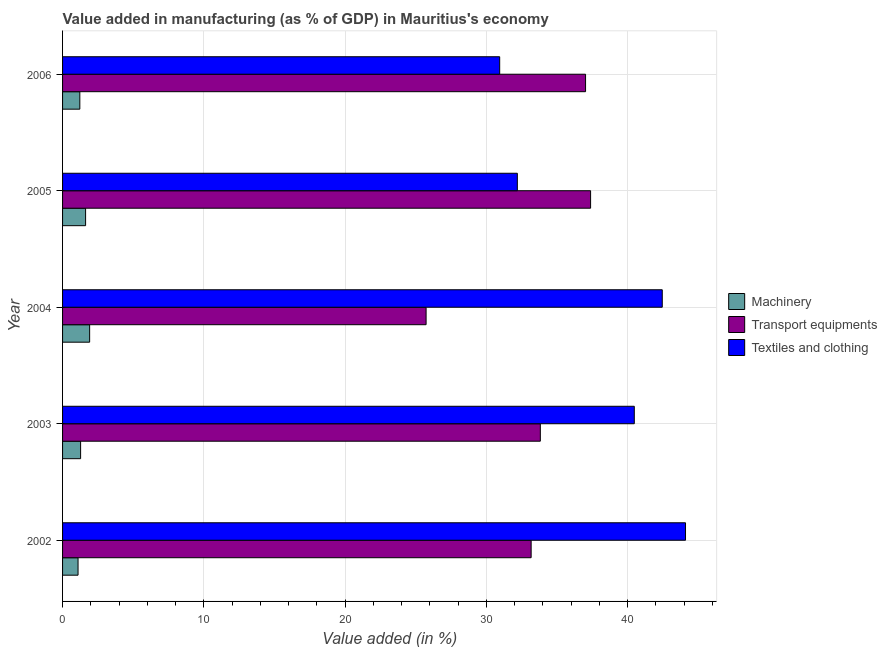How many different coloured bars are there?
Provide a short and direct response. 3. How many bars are there on the 1st tick from the bottom?
Ensure brevity in your answer.  3. In how many cases, is the number of bars for a given year not equal to the number of legend labels?
Ensure brevity in your answer.  0. What is the value added in manufacturing machinery in 2002?
Provide a succinct answer. 1.1. Across all years, what is the maximum value added in manufacturing machinery?
Give a very brief answer. 1.92. Across all years, what is the minimum value added in manufacturing transport equipments?
Your response must be concise. 25.73. In which year was the value added in manufacturing textile and clothing minimum?
Make the answer very short. 2006. What is the total value added in manufacturing transport equipments in the graph?
Make the answer very short. 167.1. What is the difference between the value added in manufacturing textile and clothing in 2004 and that in 2005?
Provide a short and direct response. 10.26. What is the difference between the value added in manufacturing textile and clothing in 2002 and the value added in manufacturing transport equipments in 2004?
Your answer should be very brief. 18.36. What is the average value added in manufacturing textile and clothing per year?
Offer a very short reply. 38.02. In the year 2003, what is the difference between the value added in manufacturing transport equipments and value added in manufacturing textile and clothing?
Give a very brief answer. -6.65. In how many years, is the value added in manufacturing machinery greater than 30 %?
Make the answer very short. 0. What is the ratio of the value added in manufacturing machinery in 2002 to that in 2006?
Keep it short and to the point. 0.9. Is the value added in manufacturing textile and clothing in 2002 less than that in 2006?
Give a very brief answer. No. Is the difference between the value added in manufacturing machinery in 2004 and 2006 greater than the difference between the value added in manufacturing textile and clothing in 2004 and 2006?
Keep it short and to the point. No. What is the difference between the highest and the second highest value added in manufacturing transport equipments?
Give a very brief answer. 0.35. What is the difference between the highest and the lowest value added in manufacturing machinery?
Your answer should be very brief. 0.82. In how many years, is the value added in manufacturing machinery greater than the average value added in manufacturing machinery taken over all years?
Your response must be concise. 2. Is the sum of the value added in manufacturing transport equipments in 2003 and 2005 greater than the maximum value added in manufacturing textile and clothing across all years?
Your response must be concise. Yes. What does the 1st bar from the top in 2002 represents?
Offer a very short reply. Textiles and clothing. What does the 3rd bar from the bottom in 2004 represents?
Provide a succinct answer. Textiles and clothing. How many years are there in the graph?
Provide a succinct answer. 5. What is the difference between two consecutive major ticks on the X-axis?
Give a very brief answer. 10. Does the graph contain grids?
Give a very brief answer. Yes. Where does the legend appear in the graph?
Offer a terse response. Center right. How many legend labels are there?
Your answer should be compact. 3. What is the title of the graph?
Your answer should be compact. Value added in manufacturing (as % of GDP) in Mauritius's economy. Does "Renewable sources" appear as one of the legend labels in the graph?
Make the answer very short. No. What is the label or title of the X-axis?
Keep it short and to the point. Value added (in %). What is the label or title of the Y-axis?
Offer a terse response. Year. What is the Value added (in %) in Machinery in 2002?
Provide a succinct answer. 1.1. What is the Value added (in %) in Transport equipments in 2002?
Your response must be concise. 33.16. What is the Value added (in %) of Textiles and clothing in 2002?
Your response must be concise. 44.09. What is the Value added (in %) of Machinery in 2003?
Give a very brief answer. 1.28. What is the Value added (in %) in Transport equipments in 2003?
Offer a terse response. 33.81. What is the Value added (in %) in Textiles and clothing in 2003?
Offer a terse response. 40.47. What is the Value added (in %) in Machinery in 2004?
Your answer should be compact. 1.92. What is the Value added (in %) of Transport equipments in 2004?
Provide a short and direct response. 25.73. What is the Value added (in %) in Textiles and clothing in 2004?
Give a very brief answer. 42.44. What is the Value added (in %) of Machinery in 2005?
Provide a short and direct response. 1.63. What is the Value added (in %) in Transport equipments in 2005?
Provide a succinct answer. 37.37. What is the Value added (in %) in Textiles and clothing in 2005?
Your answer should be very brief. 32.19. What is the Value added (in %) in Machinery in 2006?
Provide a succinct answer. 1.22. What is the Value added (in %) in Transport equipments in 2006?
Keep it short and to the point. 37.02. What is the Value added (in %) in Textiles and clothing in 2006?
Ensure brevity in your answer.  30.94. Across all years, what is the maximum Value added (in %) in Machinery?
Provide a short and direct response. 1.92. Across all years, what is the maximum Value added (in %) in Transport equipments?
Provide a short and direct response. 37.37. Across all years, what is the maximum Value added (in %) of Textiles and clothing?
Your answer should be compact. 44.09. Across all years, what is the minimum Value added (in %) in Machinery?
Your response must be concise. 1.1. Across all years, what is the minimum Value added (in %) of Transport equipments?
Offer a terse response. 25.73. Across all years, what is the minimum Value added (in %) in Textiles and clothing?
Make the answer very short. 30.94. What is the total Value added (in %) in Machinery in the graph?
Give a very brief answer. 7.14. What is the total Value added (in %) of Transport equipments in the graph?
Your answer should be compact. 167.1. What is the total Value added (in %) in Textiles and clothing in the graph?
Offer a very short reply. 190.13. What is the difference between the Value added (in %) of Machinery in 2002 and that in 2003?
Keep it short and to the point. -0.18. What is the difference between the Value added (in %) in Transport equipments in 2002 and that in 2003?
Your answer should be compact. -0.65. What is the difference between the Value added (in %) of Textiles and clothing in 2002 and that in 2003?
Give a very brief answer. 3.63. What is the difference between the Value added (in %) of Machinery in 2002 and that in 2004?
Provide a short and direct response. -0.82. What is the difference between the Value added (in %) of Transport equipments in 2002 and that in 2004?
Make the answer very short. 7.43. What is the difference between the Value added (in %) of Textiles and clothing in 2002 and that in 2004?
Provide a succinct answer. 1.65. What is the difference between the Value added (in %) in Machinery in 2002 and that in 2005?
Give a very brief answer. -0.53. What is the difference between the Value added (in %) of Transport equipments in 2002 and that in 2005?
Make the answer very short. -4.21. What is the difference between the Value added (in %) in Textiles and clothing in 2002 and that in 2005?
Provide a succinct answer. 11.9. What is the difference between the Value added (in %) of Machinery in 2002 and that in 2006?
Keep it short and to the point. -0.13. What is the difference between the Value added (in %) in Transport equipments in 2002 and that in 2006?
Give a very brief answer. -3.85. What is the difference between the Value added (in %) in Textiles and clothing in 2002 and that in 2006?
Ensure brevity in your answer.  13.15. What is the difference between the Value added (in %) in Machinery in 2003 and that in 2004?
Your response must be concise. -0.64. What is the difference between the Value added (in %) in Transport equipments in 2003 and that in 2004?
Give a very brief answer. 8.09. What is the difference between the Value added (in %) of Textiles and clothing in 2003 and that in 2004?
Provide a short and direct response. -1.98. What is the difference between the Value added (in %) in Machinery in 2003 and that in 2005?
Offer a very short reply. -0.35. What is the difference between the Value added (in %) in Transport equipments in 2003 and that in 2005?
Ensure brevity in your answer.  -3.56. What is the difference between the Value added (in %) of Textiles and clothing in 2003 and that in 2005?
Ensure brevity in your answer.  8.28. What is the difference between the Value added (in %) of Machinery in 2003 and that in 2006?
Make the answer very short. 0.06. What is the difference between the Value added (in %) in Transport equipments in 2003 and that in 2006?
Provide a short and direct response. -3.2. What is the difference between the Value added (in %) of Textiles and clothing in 2003 and that in 2006?
Provide a succinct answer. 9.53. What is the difference between the Value added (in %) in Machinery in 2004 and that in 2005?
Ensure brevity in your answer.  0.29. What is the difference between the Value added (in %) in Transport equipments in 2004 and that in 2005?
Ensure brevity in your answer.  -11.64. What is the difference between the Value added (in %) in Textiles and clothing in 2004 and that in 2005?
Give a very brief answer. 10.26. What is the difference between the Value added (in %) of Machinery in 2004 and that in 2006?
Your response must be concise. 0.69. What is the difference between the Value added (in %) of Transport equipments in 2004 and that in 2006?
Make the answer very short. -11.29. What is the difference between the Value added (in %) in Textiles and clothing in 2004 and that in 2006?
Your answer should be very brief. 11.51. What is the difference between the Value added (in %) of Machinery in 2005 and that in 2006?
Keep it short and to the point. 0.41. What is the difference between the Value added (in %) in Transport equipments in 2005 and that in 2006?
Keep it short and to the point. 0.36. What is the difference between the Value added (in %) of Textiles and clothing in 2005 and that in 2006?
Offer a terse response. 1.25. What is the difference between the Value added (in %) of Machinery in 2002 and the Value added (in %) of Transport equipments in 2003?
Offer a very short reply. -32.72. What is the difference between the Value added (in %) in Machinery in 2002 and the Value added (in %) in Textiles and clothing in 2003?
Provide a succinct answer. -39.37. What is the difference between the Value added (in %) of Transport equipments in 2002 and the Value added (in %) of Textiles and clothing in 2003?
Ensure brevity in your answer.  -7.3. What is the difference between the Value added (in %) of Machinery in 2002 and the Value added (in %) of Transport equipments in 2004?
Your answer should be compact. -24.63. What is the difference between the Value added (in %) in Machinery in 2002 and the Value added (in %) in Textiles and clothing in 2004?
Keep it short and to the point. -41.35. What is the difference between the Value added (in %) in Transport equipments in 2002 and the Value added (in %) in Textiles and clothing in 2004?
Make the answer very short. -9.28. What is the difference between the Value added (in %) of Machinery in 2002 and the Value added (in %) of Transport equipments in 2005?
Give a very brief answer. -36.28. What is the difference between the Value added (in %) of Machinery in 2002 and the Value added (in %) of Textiles and clothing in 2005?
Provide a short and direct response. -31.09. What is the difference between the Value added (in %) of Transport equipments in 2002 and the Value added (in %) of Textiles and clothing in 2005?
Keep it short and to the point. 0.98. What is the difference between the Value added (in %) in Machinery in 2002 and the Value added (in %) in Transport equipments in 2006?
Your answer should be compact. -35.92. What is the difference between the Value added (in %) in Machinery in 2002 and the Value added (in %) in Textiles and clothing in 2006?
Ensure brevity in your answer.  -29.84. What is the difference between the Value added (in %) in Transport equipments in 2002 and the Value added (in %) in Textiles and clothing in 2006?
Your response must be concise. 2.23. What is the difference between the Value added (in %) in Machinery in 2003 and the Value added (in %) in Transport equipments in 2004?
Your response must be concise. -24.45. What is the difference between the Value added (in %) of Machinery in 2003 and the Value added (in %) of Textiles and clothing in 2004?
Keep it short and to the point. -41.17. What is the difference between the Value added (in %) of Transport equipments in 2003 and the Value added (in %) of Textiles and clothing in 2004?
Your answer should be very brief. -8.63. What is the difference between the Value added (in %) in Machinery in 2003 and the Value added (in %) in Transport equipments in 2005?
Offer a very short reply. -36.09. What is the difference between the Value added (in %) in Machinery in 2003 and the Value added (in %) in Textiles and clothing in 2005?
Make the answer very short. -30.91. What is the difference between the Value added (in %) in Transport equipments in 2003 and the Value added (in %) in Textiles and clothing in 2005?
Ensure brevity in your answer.  1.63. What is the difference between the Value added (in %) of Machinery in 2003 and the Value added (in %) of Transport equipments in 2006?
Offer a very short reply. -35.74. What is the difference between the Value added (in %) in Machinery in 2003 and the Value added (in %) in Textiles and clothing in 2006?
Provide a short and direct response. -29.66. What is the difference between the Value added (in %) in Transport equipments in 2003 and the Value added (in %) in Textiles and clothing in 2006?
Give a very brief answer. 2.88. What is the difference between the Value added (in %) of Machinery in 2004 and the Value added (in %) of Transport equipments in 2005?
Provide a succinct answer. -35.46. What is the difference between the Value added (in %) in Machinery in 2004 and the Value added (in %) in Textiles and clothing in 2005?
Offer a very short reply. -30.27. What is the difference between the Value added (in %) in Transport equipments in 2004 and the Value added (in %) in Textiles and clothing in 2005?
Make the answer very short. -6.46. What is the difference between the Value added (in %) of Machinery in 2004 and the Value added (in %) of Transport equipments in 2006?
Provide a short and direct response. -35.1. What is the difference between the Value added (in %) of Machinery in 2004 and the Value added (in %) of Textiles and clothing in 2006?
Your answer should be compact. -29.02. What is the difference between the Value added (in %) of Transport equipments in 2004 and the Value added (in %) of Textiles and clothing in 2006?
Your answer should be very brief. -5.21. What is the difference between the Value added (in %) of Machinery in 2005 and the Value added (in %) of Transport equipments in 2006?
Your answer should be very brief. -35.39. What is the difference between the Value added (in %) of Machinery in 2005 and the Value added (in %) of Textiles and clothing in 2006?
Ensure brevity in your answer.  -29.31. What is the difference between the Value added (in %) in Transport equipments in 2005 and the Value added (in %) in Textiles and clothing in 2006?
Keep it short and to the point. 6.43. What is the average Value added (in %) of Machinery per year?
Offer a very short reply. 1.43. What is the average Value added (in %) of Transport equipments per year?
Your response must be concise. 33.42. What is the average Value added (in %) of Textiles and clothing per year?
Your answer should be compact. 38.03. In the year 2002, what is the difference between the Value added (in %) in Machinery and Value added (in %) in Transport equipments?
Offer a very short reply. -32.07. In the year 2002, what is the difference between the Value added (in %) of Machinery and Value added (in %) of Textiles and clothing?
Your response must be concise. -42.99. In the year 2002, what is the difference between the Value added (in %) of Transport equipments and Value added (in %) of Textiles and clothing?
Offer a very short reply. -10.93. In the year 2003, what is the difference between the Value added (in %) in Machinery and Value added (in %) in Transport equipments?
Your answer should be compact. -32.54. In the year 2003, what is the difference between the Value added (in %) of Machinery and Value added (in %) of Textiles and clothing?
Provide a short and direct response. -39.19. In the year 2003, what is the difference between the Value added (in %) in Transport equipments and Value added (in %) in Textiles and clothing?
Provide a succinct answer. -6.65. In the year 2004, what is the difference between the Value added (in %) in Machinery and Value added (in %) in Transport equipments?
Your answer should be compact. -23.81. In the year 2004, what is the difference between the Value added (in %) of Machinery and Value added (in %) of Textiles and clothing?
Keep it short and to the point. -40.53. In the year 2004, what is the difference between the Value added (in %) in Transport equipments and Value added (in %) in Textiles and clothing?
Your answer should be very brief. -16.72. In the year 2005, what is the difference between the Value added (in %) in Machinery and Value added (in %) in Transport equipments?
Your answer should be very brief. -35.74. In the year 2005, what is the difference between the Value added (in %) of Machinery and Value added (in %) of Textiles and clothing?
Provide a short and direct response. -30.56. In the year 2005, what is the difference between the Value added (in %) in Transport equipments and Value added (in %) in Textiles and clothing?
Provide a short and direct response. 5.18. In the year 2006, what is the difference between the Value added (in %) of Machinery and Value added (in %) of Transport equipments?
Keep it short and to the point. -35.79. In the year 2006, what is the difference between the Value added (in %) in Machinery and Value added (in %) in Textiles and clothing?
Your answer should be compact. -29.72. In the year 2006, what is the difference between the Value added (in %) of Transport equipments and Value added (in %) of Textiles and clothing?
Your answer should be compact. 6.08. What is the ratio of the Value added (in %) of Machinery in 2002 to that in 2003?
Your response must be concise. 0.86. What is the ratio of the Value added (in %) of Transport equipments in 2002 to that in 2003?
Keep it short and to the point. 0.98. What is the ratio of the Value added (in %) of Textiles and clothing in 2002 to that in 2003?
Your answer should be very brief. 1.09. What is the ratio of the Value added (in %) in Machinery in 2002 to that in 2004?
Your answer should be compact. 0.57. What is the ratio of the Value added (in %) in Transport equipments in 2002 to that in 2004?
Ensure brevity in your answer.  1.29. What is the ratio of the Value added (in %) in Textiles and clothing in 2002 to that in 2004?
Make the answer very short. 1.04. What is the ratio of the Value added (in %) in Machinery in 2002 to that in 2005?
Offer a terse response. 0.67. What is the ratio of the Value added (in %) in Transport equipments in 2002 to that in 2005?
Give a very brief answer. 0.89. What is the ratio of the Value added (in %) in Textiles and clothing in 2002 to that in 2005?
Your answer should be very brief. 1.37. What is the ratio of the Value added (in %) of Machinery in 2002 to that in 2006?
Keep it short and to the point. 0.9. What is the ratio of the Value added (in %) of Transport equipments in 2002 to that in 2006?
Ensure brevity in your answer.  0.9. What is the ratio of the Value added (in %) in Textiles and clothing in 2002 to that in 2006?
Your response must be concise. 1.43. What is the ratio of the Value added (in %) of Transport equipments in 2003 to that in 2004?
Your response must be concise. 1.31. What is the ratio of the Value added (in %) of Textiles and clothing in 2003 to that in 2004?
Your answer should be very brief. 0.95. What is the ratio of the Value added (in %) in Machinery in 2003 to that in 2005?
Your response must be concise. 0.78. What is the ratio of the Value added (in %) of Transport equipments in 2003 to that in 2005?
Offer a terse response. 0.9. What is the ratio of the Value added (in %) of Textiles and clothing in 2003 to that in 2005?
Provide a succinct answer. 1.26. What is the ratio of the Value added (in %) in Machinery in 2003 to that in 2006?
Ensure brevity in your answer.  1.05. What is the ratio of the Value added (in %) of Transport equipments in 2003 to that in 2006?
Offer a very short reply. 0.91. What is the ratio of the Value added (in %) in Textiles and clothing in 2003 to that in 2006?
Your response must be concise. 1.31. What is the ratio of the Value added (in %) of Machinery in 2004 to that in 2005?
Offer a terse response. 1.18. What is the ratio of the Value added (in %) of Transport equipments in 2004 to that in 2005?
Offer a terse response. 0.69. What is the ratio of the Value added (in %) in Textiles and clothing in 2004 to that in 2005?
Keep it short and to the point. 1.32. What is the ratio of the Value added (in %) in Machinery in 2004 to that in 2006?
Offer a terse response. 1.57. What is the ratio of the Value added (in %) in Transport equipments in 2004 to that in 2006?
Offer a terse response. 0.7. What is the ratio of the Value added (in %) of Textiles and clothing in 2004 to that in 2006?
Provide a short and direct response. 1.37. What is the ratio of the Value added (in %) of Machinery in 2005 to that in 2006?
Ensure brevity in your answer.  1.33. What is the ratio of the Value added (in %) of Transport equipments in 2005 to that in 2006?
Provide a succinct answer. 1.01. What is the ratio of the Value added (in %) in Textiles and clothing in 2005 to that in 2006?
Your answer should be compact. 1.04. What is the difference between the highest and the second highest Value added (in %) in Machinery?
Keep it short and to the point. 0.29. What is the difference between the highest and the second highest Value added (in %) of Transport equipments?
Keep it short and to the point. 0.36. What is the difference between the highest and the second highest Value added (in %) in Textiles and clothing?
Your answer should be very brief. 1.65. What is the difference between the highest and the lowest Value added (in %) in Machinery?
Your answer should be very brief. 0.82. What is the difference between the highest and the lowest Value added (in %) in Transport equipments?
Provide a short and direct response. 11.64. What is the difference between the highest and the lowest Value added (in %) in Textiles and clothing?
Provide a short and direct response. 13.15. 